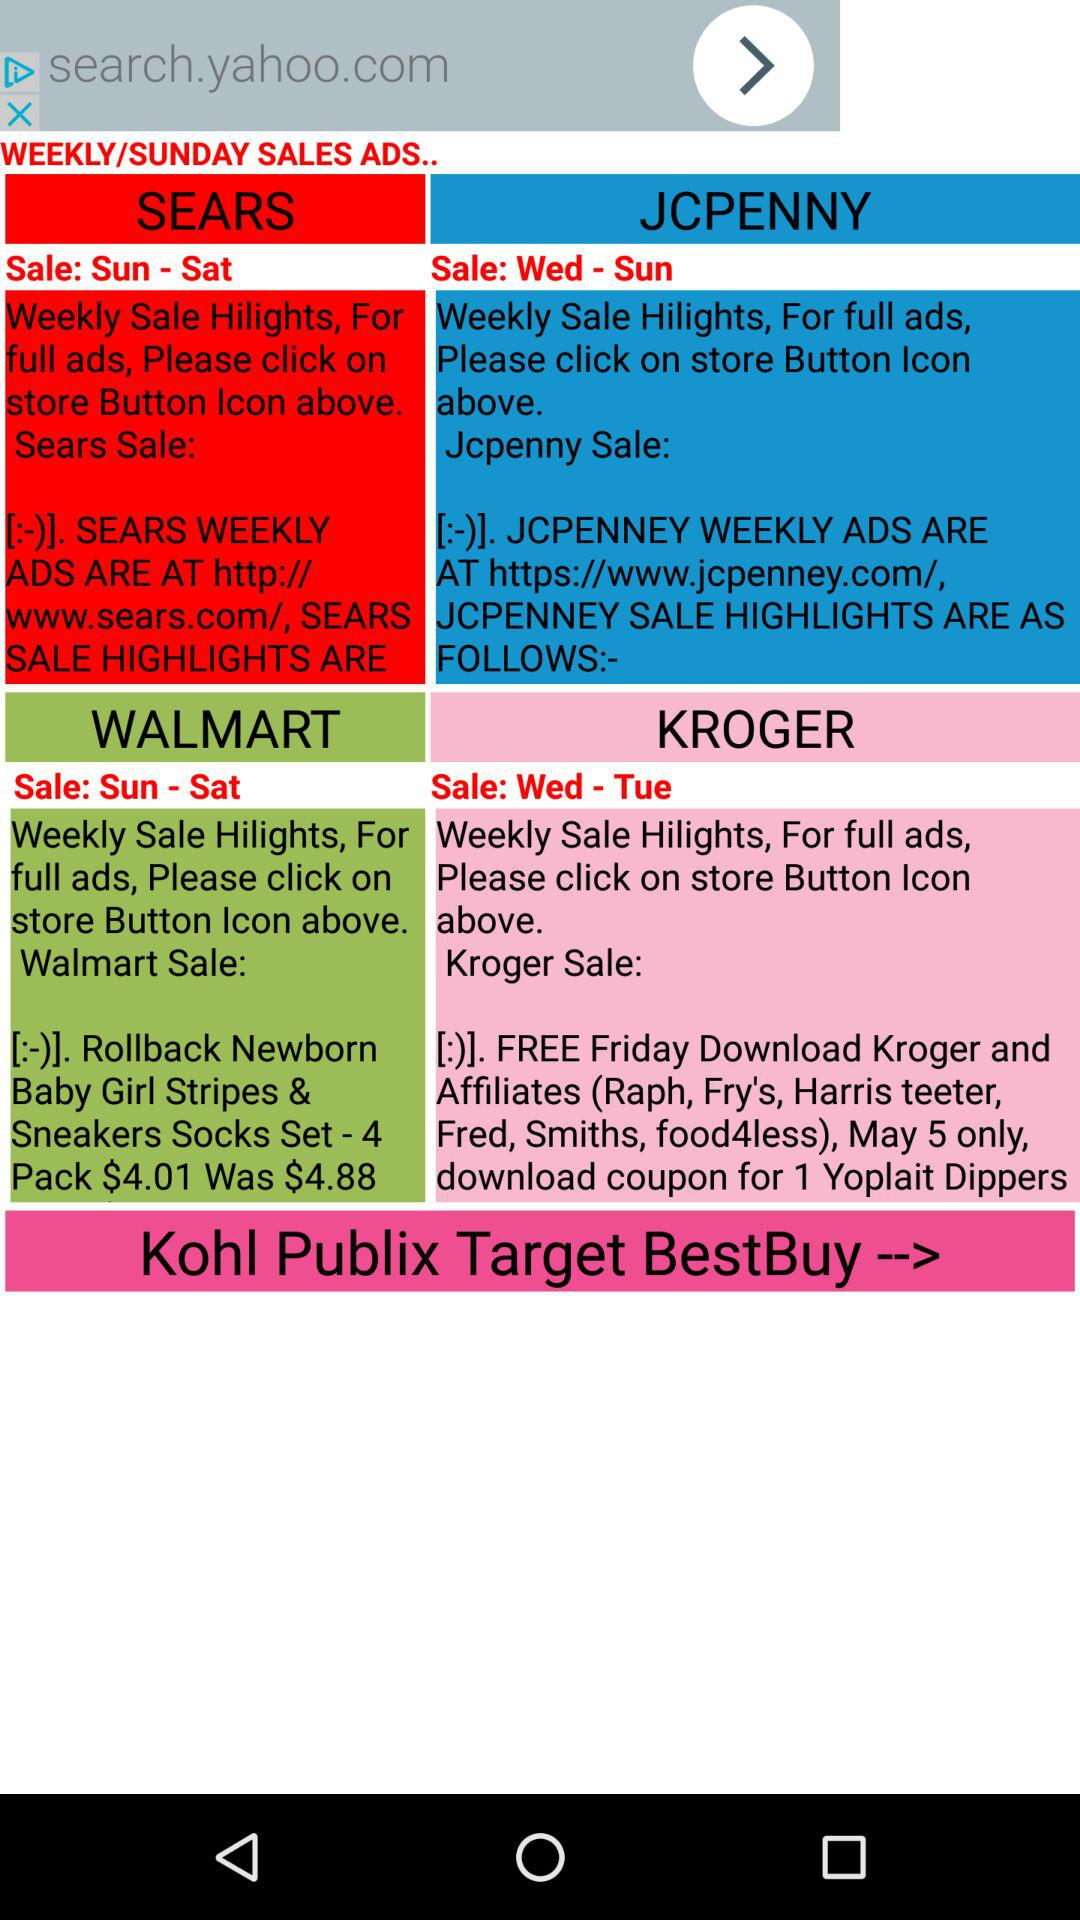What's the sale price of "Rollback Newborn Baby Girl Stripes & Sneakers Socks Set - 4 pack"? The sale price is $4.01. 